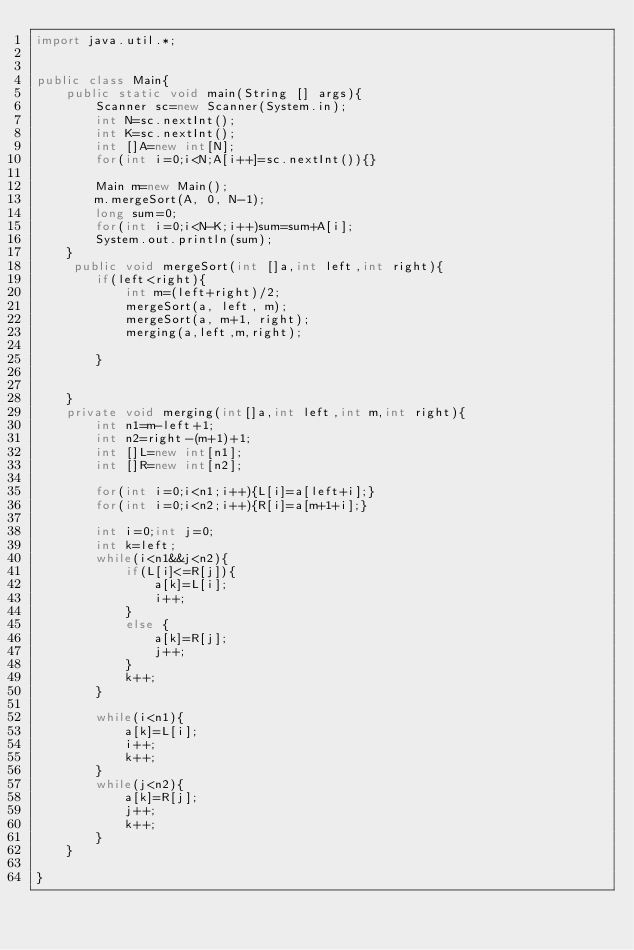Convert code to text. <code><loc_0><loc_0><loc_500><loc_500><_Java_>import java.util.*;


public class Main{
    public static void main(String [] args){
        Scanner sc=new Scanner(System.in);
        int N=sc.nextInt();
        int K=sc.nextInt();
        int []A=new int[N];
        for(int i=0;i<N;A[i++]=sc.nextInt()){}
        
        Main m=new Main();
        m.mergeSort(A, 0, N-1);
        long sum=0;
        for(int i=0;i<N-K;i++)sum=sum+A[i];
        System.out.println(sum);
    }
     public void mergeSort(int []a,int left,int right){
        if(left<right){
            int m=(left+right)/2;
            mergeSort(a, left, m);
            mergeSort(a, m+1, right);
            merging(a,left,m,right);
            
        }
        
        
    }
    private void merging(int[]a,int left,int m,int right){
        int n1=m-left+1;
        int n2=right-(m+1)+1;
        int []L=new int[n1];
        int []R=new int[n2];
        
        for(int i=0;i<n1;i++){L[i]=a[left+i];}
        for(int i=0;i<n2;i++){R[i]=a[m+1+i];}
        
        int i=0;int j=0;
        int k=left;
        while(i<n1&&j<n2){
            if(L[i]<=R[j]){
                a[k]=L[i];
                i++;
            }
            else {
                a[k]=R[j];
                j++;
            }
            k++;
        }
        
        while(i<n1){
            a[k]=L[i];
            i++;
            k++;
        }
        while(j<n2){
            a[k]=R[j];
            j++;
            k++;
        }
    }
    
}

</code> 